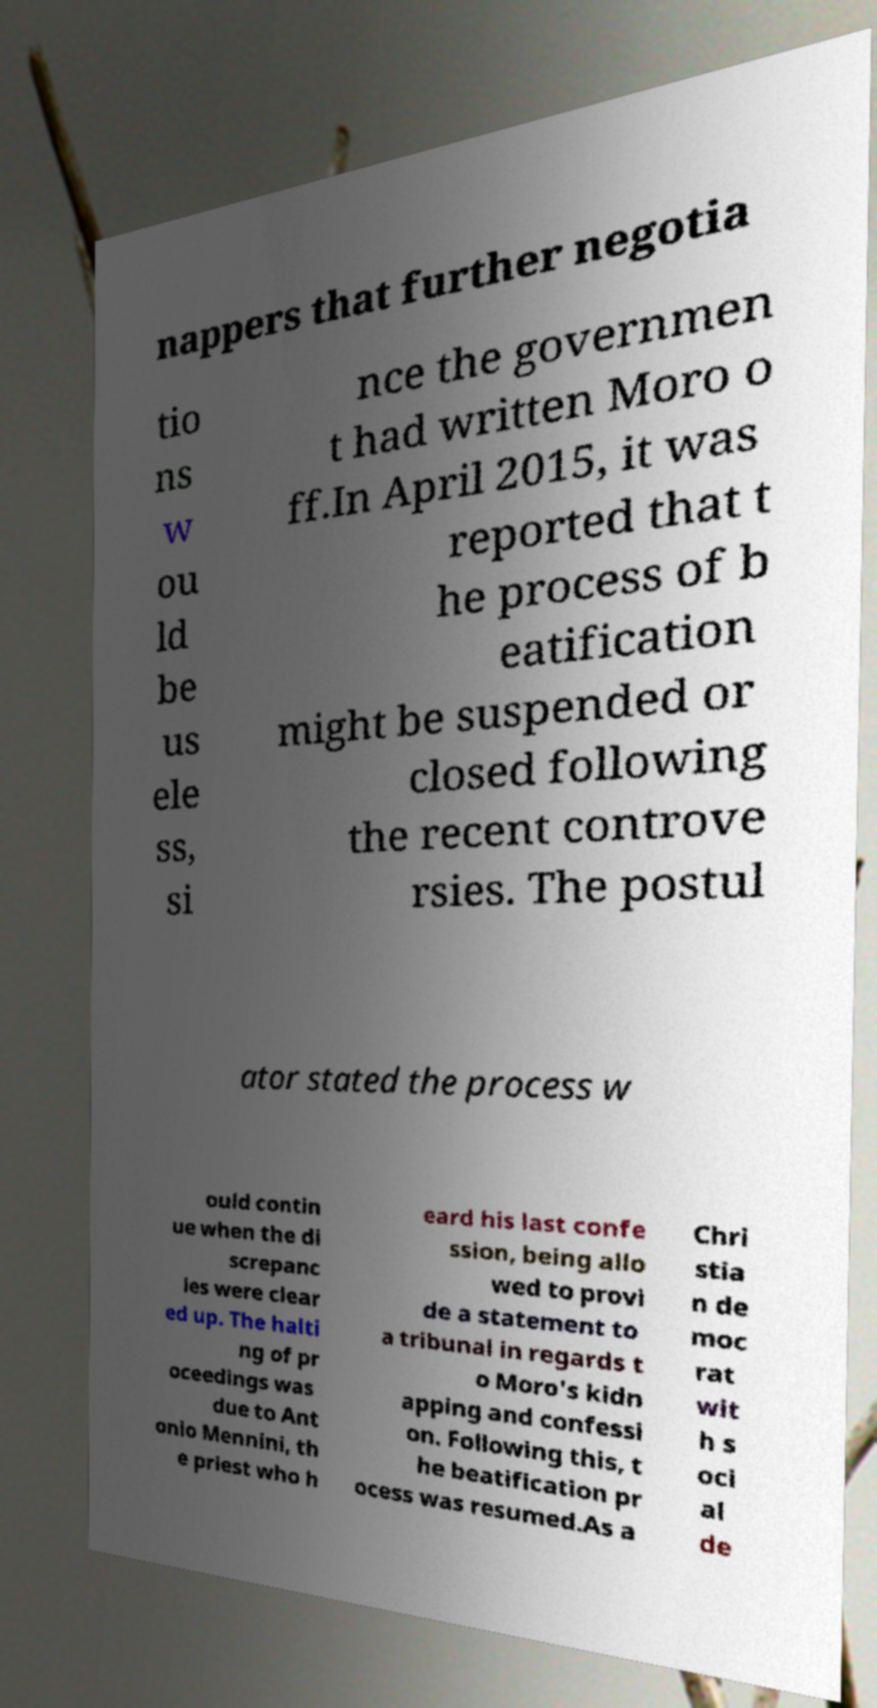What messages or text are displayed in this image? I need them in a readable, typed format. nappers that further negotia tio ns w ou ld be us ele ss, si nce the governmen t had written Moro o ff.In April 2015, it was reported that t he process of b eatification might be suspended or closed following the recent controve rsies. The postul ator stated the process w ould contin ue when the di screpanc ies were clear ed up. The halti ng of pr oceedings was due to Ant onio Mennini, th e priest who h eard his last confe ssion, being allo wed to provi de a statement to a tribunal in regards t o Moro's kidn apping and confessi on. Following this, t he beatification pr ocess was resumed.As a Chri stia n de moc rat wit h s oci al de 